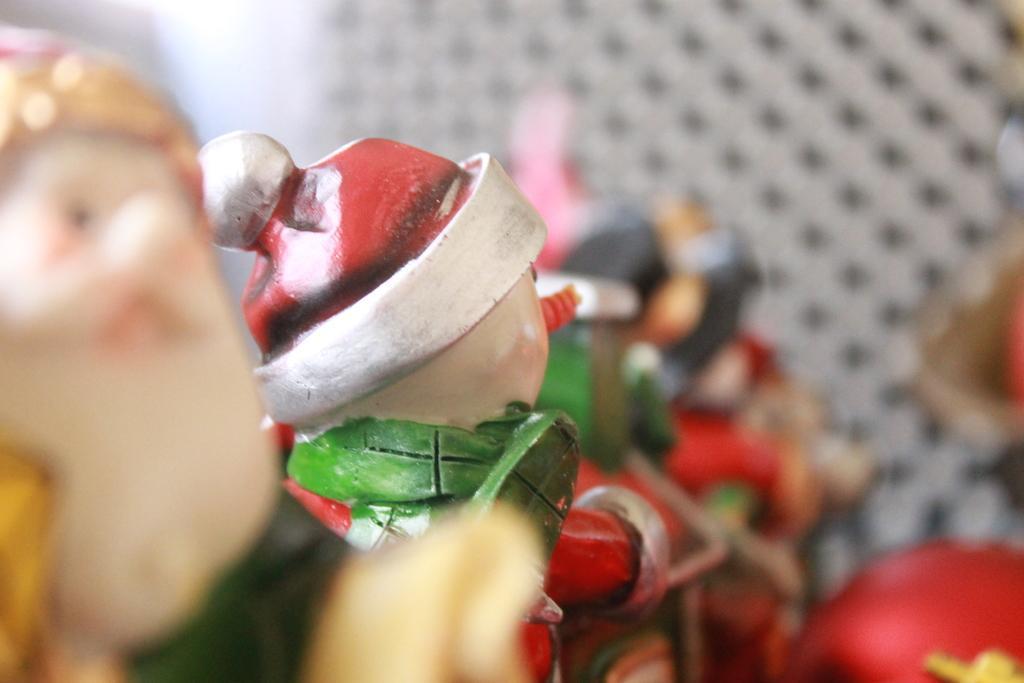Could you give a brief overview of what you see in this image? In this image we can see some dolls. 